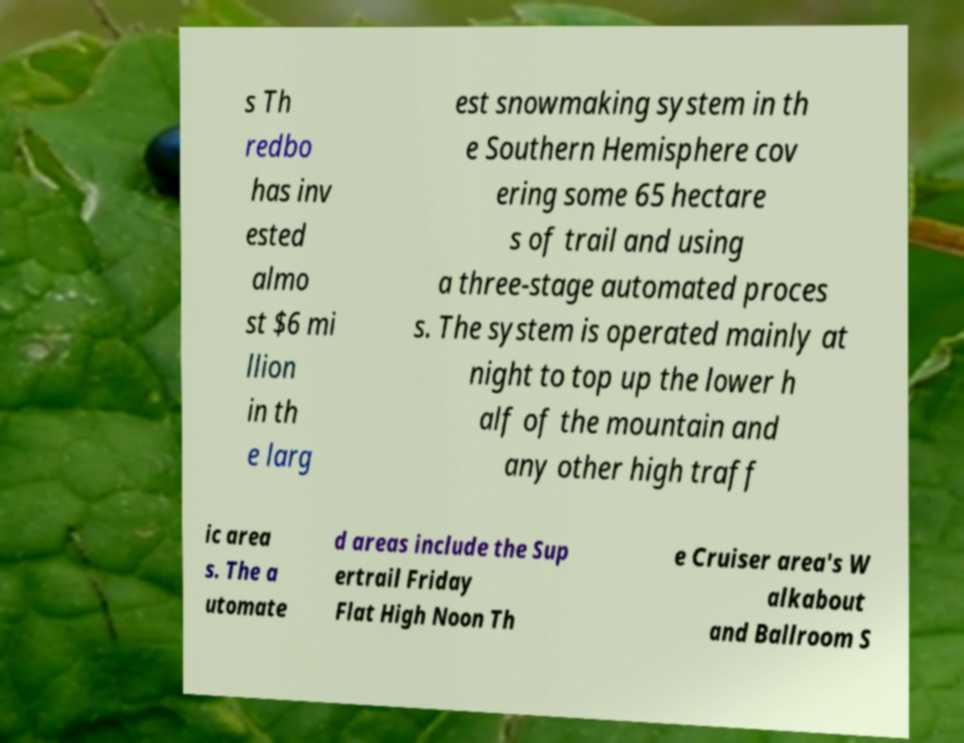For documentation purposes, I need the text within this image transcribed. Could you provide that? s Th redbo has inv ested almo st $6 mi llion in th e larg est snowmaking system in th e Southern Hemisphere cov ering some 65 hectare s of trail and using a three-stage automated proces s. The system is operated mainly at night to top up the lower h alf of the mountain and any other high traff ic area s. The a utomate d areas include the Sup ertrail Friday Flat High Noon Th e Cruiser area's W alkabout and Ballroom S 